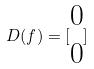Convert formula to latex. <formula><loc_0><loc_0><loc_500><loc_500>D ( f ) = [ \begin{matrix} 0 \\ 0 \end{matrix} ]</formula> 